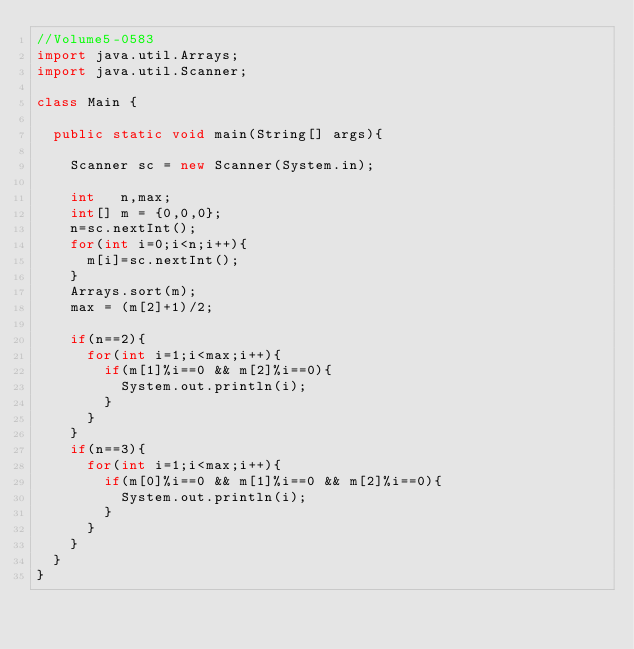Convert code to text. <code><loc_0><loc_0><loc_500><loc_500><_Java_>//Volume5-0583
import java.util.Arrays;
import java.util.Scanner;

class Main {

	public static void main(String[] args){

		Scanner sc = new Scanner(System.in);

		int   n,max;
		int[] m = {0,0,0};
		n=sc.nextInt();
		for(int i=0;i<n;i++){
			m[i]=sc.nextInt();
		}
		Arrays.sort(m);
		max = (m[2]+1)/2;

		if(n==2){
			for(int i=1;i<max;i++){
				if(m[1]%i==0 && m[2]%i==0){
					System.out.println(i);
				}
			}
		}
		if(n==3){
			for(int i=1;i<max;i++){
				if(m[0]%i==0 && m[1]%i==0 && m[2]%i==0){
					System.out.println(i);
				}
			}
		}
	}
}</code> 